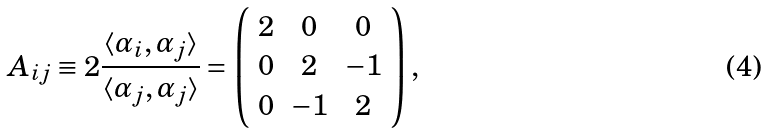Convert formula to latex. <formula><loc_0><loc_0><loc_500><loc_500>A _ { i j } \equiv 2 \frac { \langle \alpha _ { i } , \alpha _ { j } \rangle } { \langle \alpha _ { j } , \alpha _ { j } \rangle } = \left ( \begin{array} { c c c } 2 & 0 & 0 \\ 0 & 2 & - 1 \\ 0 & - 1 & 2 \\ \end{array} \right ) ,</formula> 